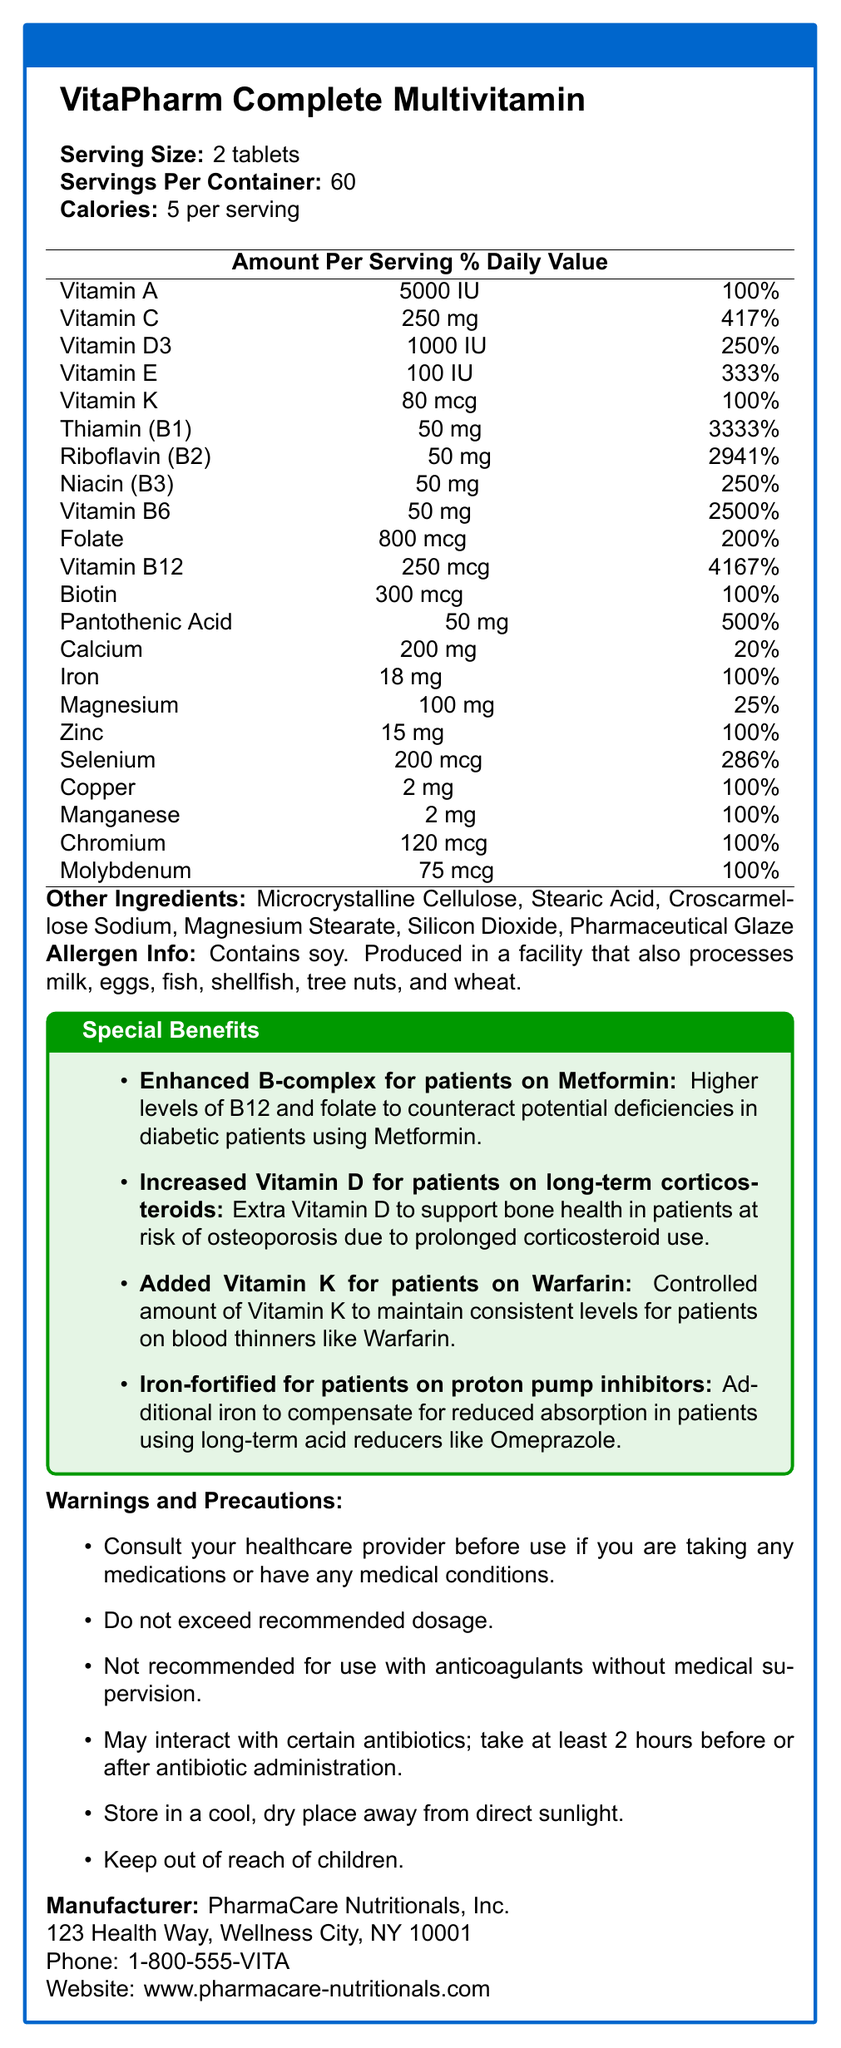what is the serving size? The document states that the serving size for VitaPharm Complete Multivitamin is 2 tablets.
Answer: 2 tablets how many calories are in each serving? According to the document, each serving contains 5 calories.
Answer: 5 calories what is the daily value percentage of vitamin D3 per serving? The document indicates that each serving provides 1000 IU of Vitamin D3, which is 250% of the daily value.
Answer: 250% which ingredient is present at 3333% of the daily value? The document specifies that each serving contains 50 mg of Thiamin (B1), amounting to 3333% of the daily value.
Answer: Thiamin (B1) how much iron is in one serving? The document lists Iron as containing 18 mg per serving, which is 100% of the daily value.
Answer: 18 mg what are the other ingredients in VitaPharm Complete Multivitamin? A. Cellulose, Stearic Acid, Sodium Chloride B. Microcrystalline Cellulose, Stearic Acid, Croscarmellose Sodium C. Cellulose, Stearic Acid, Sodium Bicarbonate D. Microcrystalline Cellulose, Stearic Acid, Sodium Citrate The document lists the other ingredients as Microcrystalline Cellulose, Stearic Acid, Croscarmellose Sodium, Magnesium Stearate, Silicon Dioxide, and Pharmaceutical Glaze.
Answer: B. Microcrystalline Cellulose, Stearic Acid, Croscarmellose Sodium which vitamins provide more than 200% of the daily value per serving? A. Vitamin A, Vitamin D3, Vitamin B12 B. Vitamin C, Vitamin E, Vitamin B6 C. Vitamin K, Folate, Vitamin B12 D. All of the above According to the document, Vitamin C (417%), Vitamin E (333%), and Vitamin B6 (2500%) provide more than 200% of the daily value per serving.
Answer: B. Vitamin C, Vitamin E, Vitamin B6 does the product contain any allergens? The document mentions that the product contains soy and is produced in a facility that processes milk, eggs, fish, shellfish, tree nuts, and wheat.
Answer: Yes summarize the special benefits of this multivitamin. According to the document, these special benefits are designed to address specific deficiencies and concerns in patients taking certain medications.
Answer: The special benefits include an enhanced B-complex for patients on Metformin, increased Vitamin D for patients on long-term corticosteroids, added Vitamin K for patients on Warfarin, and iron-fortification for patients on proton pump inhibitors. what is the daily value percentage of zinc per serving? The document indicates that each serving contains 15 mg of zinc, which is 100% of the daily value.
Answer: 100% is the multivitamin recommended for use with anticoagulants without medical supervision? The document explicitly states that the product is not recommended for use with anticoagulants without medical supervision.
Answer: No is there any information about the effect of the multivitamin on blood pressure? The document does not provide any details about the effect of the multivitamin on blood pressure.
Answer: Not enough information 